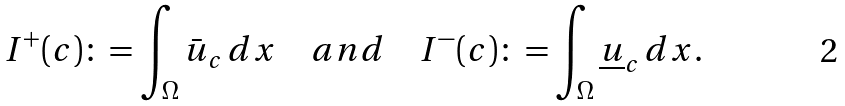Convert formula to latex. <formula><loc_0><loc_0><loc_500><loc_500>I ^ { + } ( c ) \colon = \int _ { \Omega } \bar { u } _ { c } \, d x \quad a n d \quad I ^ { - } ( c ) \colon = \int _ { \Omega } \underline { u } _ { c } \, d x .</formula> 